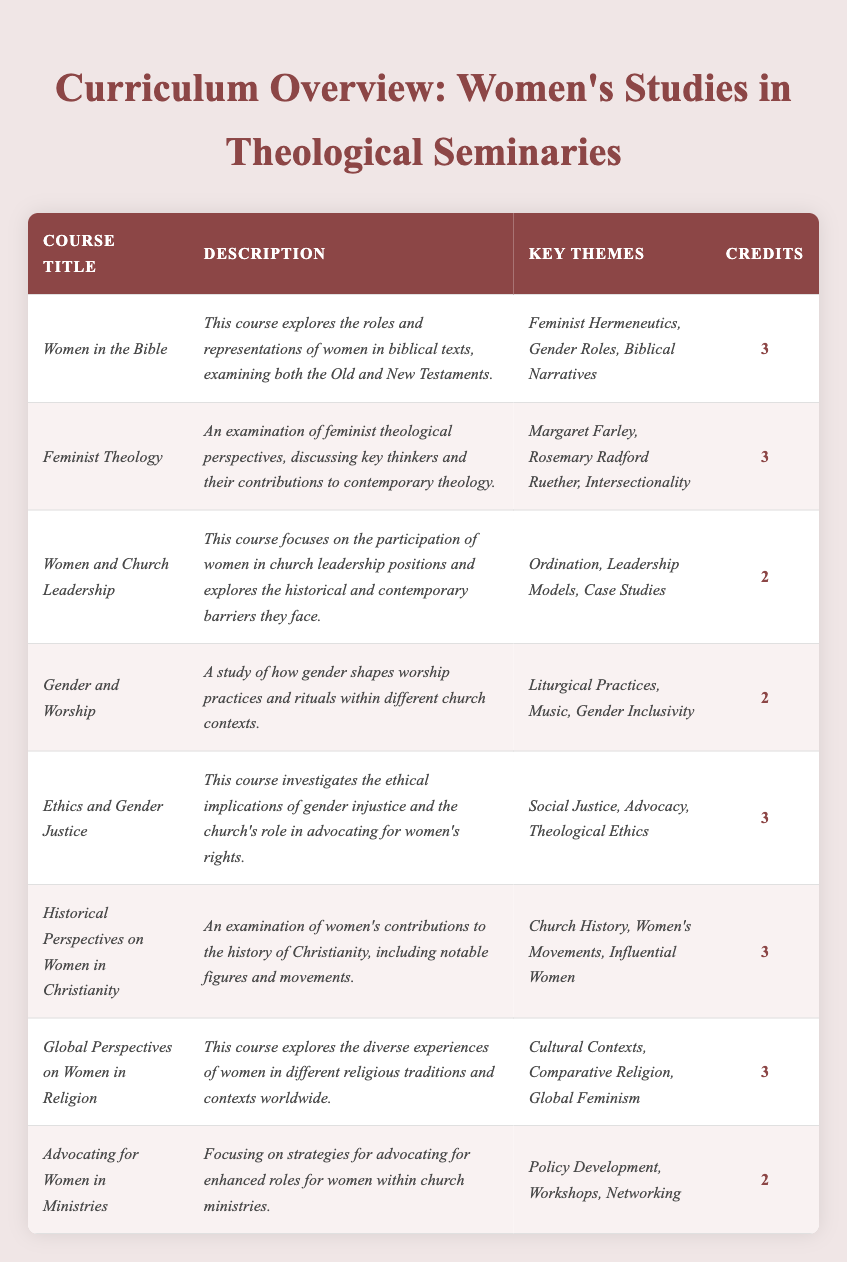What is the course title with the lowest number of credits? The courses with the lowest number of credits are "Women and Church Leadership," "Gender and Worship," and "Advocating for Women in Ministries," all with 2 credits. I will select "Women and Church Leadership" as it is listed first.
Answer: Women and Church Leadership How many courses have a credit value of 3? By reviewing the table, I can count that there are 5 courses with 3 credits: "Women in the Bible," "Feminist Theology," "Ethics and Gender Justice," "Historical Perspectives on Women in Christianity," and "Global Perspectives on Women in Religion."
Answer: 5 Is there a course that focuses on the intersection of feminist theology and practical church leadership? The course "Feminist Theology" deals with feminist perspectives, while "Women and Church Leadership" focuses on women's roles in church leadership. However, neither specifically targets the intersection of both themes in a combined manner, leading to a conclusion of no.
Answer: No What are the key themes covered in the course "Global Perspectives on Women in Religion"? The key themes are clearly listed in the table as "Cultural Contexts, Comparative Religion, Global Feminism."
Answer: Cultural Contexts, Comparative Religion, Global Feminism Which course covers the concept of gender justice and what are its key themes? The course "Ethics and Gender Justice" discusses gender justice and its ethical implications, with key themes being "Social Justice, Advocacy, Theological Ethics."
Answer: Ethics and Gender Justice; Social Justice, Advocacy, Theological Ethics Are there more courses focusing on church leadership or on worship? "Women and Church Leadership" and "Advocating for Women in Ministries" focus on church leadership (total of 2), while "Gender and Worship" focuses on worship (total of 1). Therefore, there are more courses about church leadership.
Answer: Church leadership What is the total number of credits for all courses combined? To find the total, I add the credits: 3 + 3 + 2 + 2 + 3 + 3 + 3 + 2 = 21.
Answer: 21 Which course includes the discussion of influential women in Christianity? The course titled "Historical Perspectives on Women in Christianity" explicitly mentions examining influential women, along with their contributions to Christianity.
Answer: Historical Perspectives on Women in Christianity What are the descriptions of the two courses with the least credits? The courses "Women and Church Leadership" and "Advocating for Women in Ministries" both have 2 credits. Their descriptions detail the participation of women in church leadership and strategies for advocating for women’s roles in ministries, respectively.
Answer: Women and Church Leadership, Advocating for Women in Ministries Does any course discuss key thinkers in feminist theology? Yes, the course "Feminist Theology" discusses key thinkers, including Margaret Farley and Rosemary Radford Ruether, contributing to feminist perspectives in contemporary theology.
Answer: Yes What is the common credit value for courses focusing on feminist themes and what are those courses? The courses focusing on feminist themes, specifically "Women in the Bible," "Feminist Theology," "Ethics and Gender Justice," and "Global Perspectives on Women in Religion," have a common credit value of 3 credits each.
Answer: 3 credits 